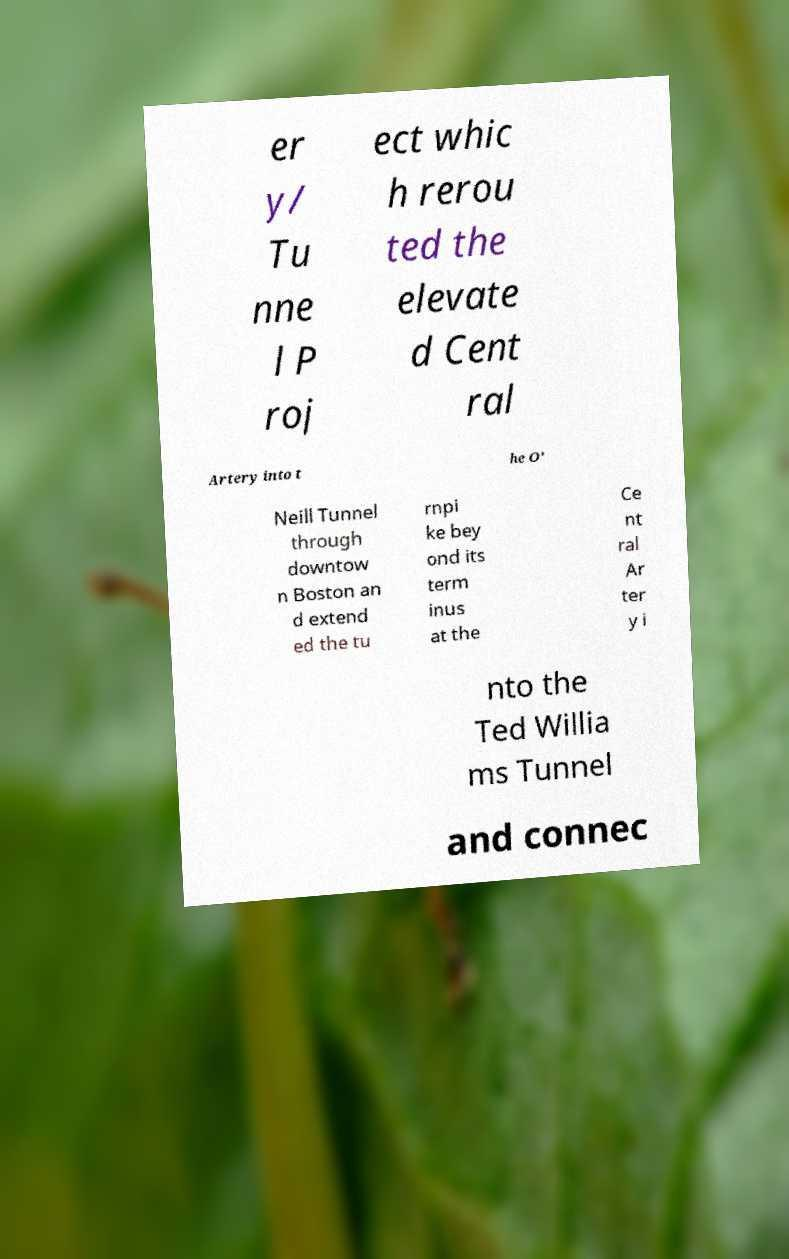Can you accurately transcribe the text from the provided image for me? er y/ Tu nne l P roj ect whic h rerou ted the elevate d Cent ral Artery into t he O' Neill Tunnel through downtow n Boston an d extend ed the tu rnpi ke bey ond its term inus at the Ce nt ral Ar ter y i nto the Ted Willia ms Tunnel and connec 